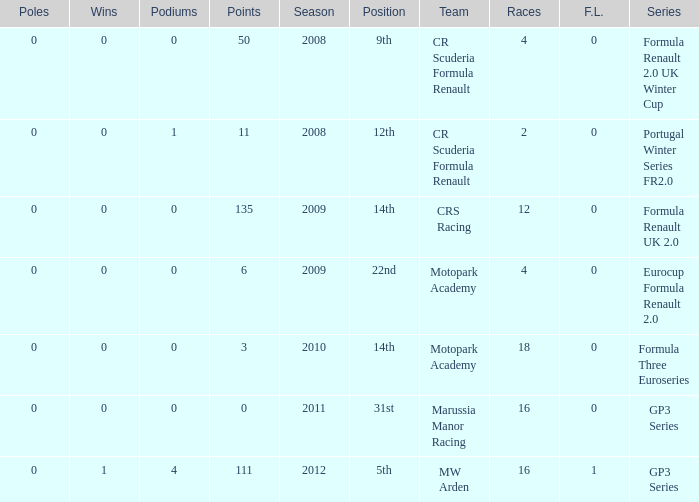How many points does Marussia Manor Racing have? 1.0. 